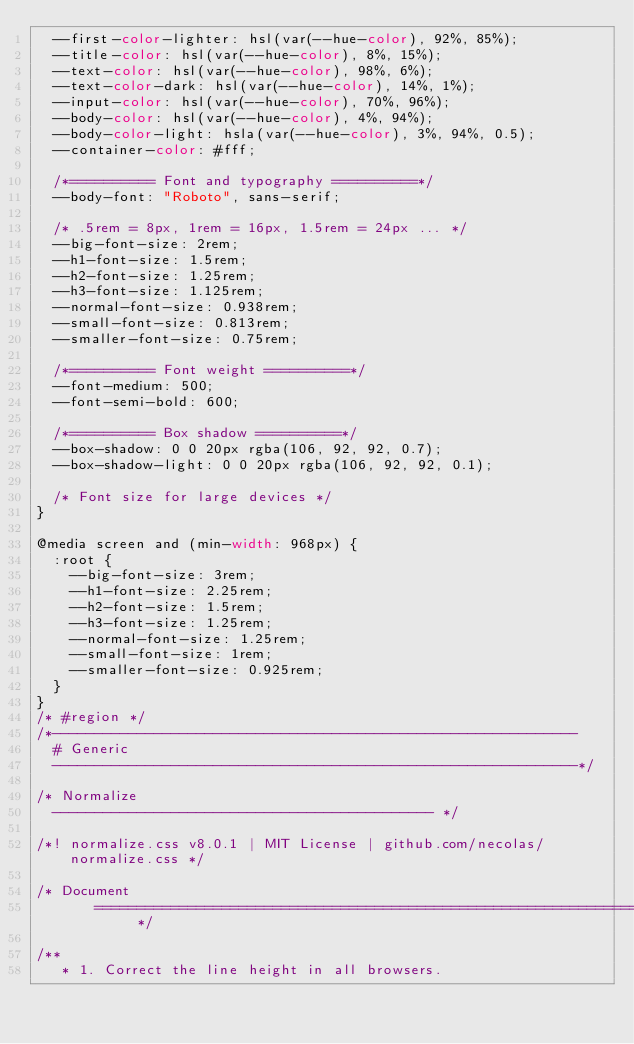Convert code to text. <code><loc_0><loc_0><loc_500><loc_500><_CSS_>  --first-color-lighter: hsl(var(--hue-color), 92%, 85%);
  --title-color: hsl(var(--hue-color), 8%, 15%);
  --text-color: hsl(var(--hue-color), 98%, 6%);
  --text-color-dark: hsl(var(--hue-color), 14%, 1%);
  --input-color: hsl(var(--hue-color), 70%, 96%);
  --body-color: hsl(var(--hue-color), 4%, 94%);
  --body-color-light: hsla(var(--hue-color), 3%, 94%, 0.5);
  --container-color: #fff;

  /*========== Font and typography ==========*/
  --body-font: "Roboto", sans-serif;

  /* .5rem = 8px, 1rem = 16px, 1.5rem = 24px ... */
  --big-font-size: 2rem;
  --h1-font-size: 1.5rem;
  --h2-font-size: 1.25rem;
  --h3-font-size: 1.125rem;
  --normal-font-size: 0.938rem;
  --small-font-size: 0.813rem;
  --smaller-font-size: 0.75rem;

  /*========== Font weight ==========*/
  --font-medium: 500;
  --font-semi-bold: 600;

  /*========== Box shadow ==========*/
  --box-shadow: 0 0 20px rgba(106, 92, 92, 0.7);
  --box-shadow-light: 0 0 20px rgba(106, 92, 92, 0.1);

  /* Font size for large devices */
}

@media screen and (min-width: 968px) {
  :root {
    --big-font-size: 3rem;
    --h1-font-size: 2.25rem;
    --h2-font-size: 1.5rem;
    --h3-font-size: 1.25rem;
    --normal-font-size: 1.25rem;
    --small-font-size: 1rem;
    --smaller-font-size: 0.925rem;
  }
}
/* #region */
/*--------------------------------------------------------------
  # Generic
  --------------------------------------------------------------*/

/* Normalize
  --------------------------------------------- */

/*! normalize.css v8.0.1 | MIT License | github.com/necolas/normalize.css */

/* Document
       ========================================================================== */

/**
   * 1. Correct the line height in all browsers.</code> 